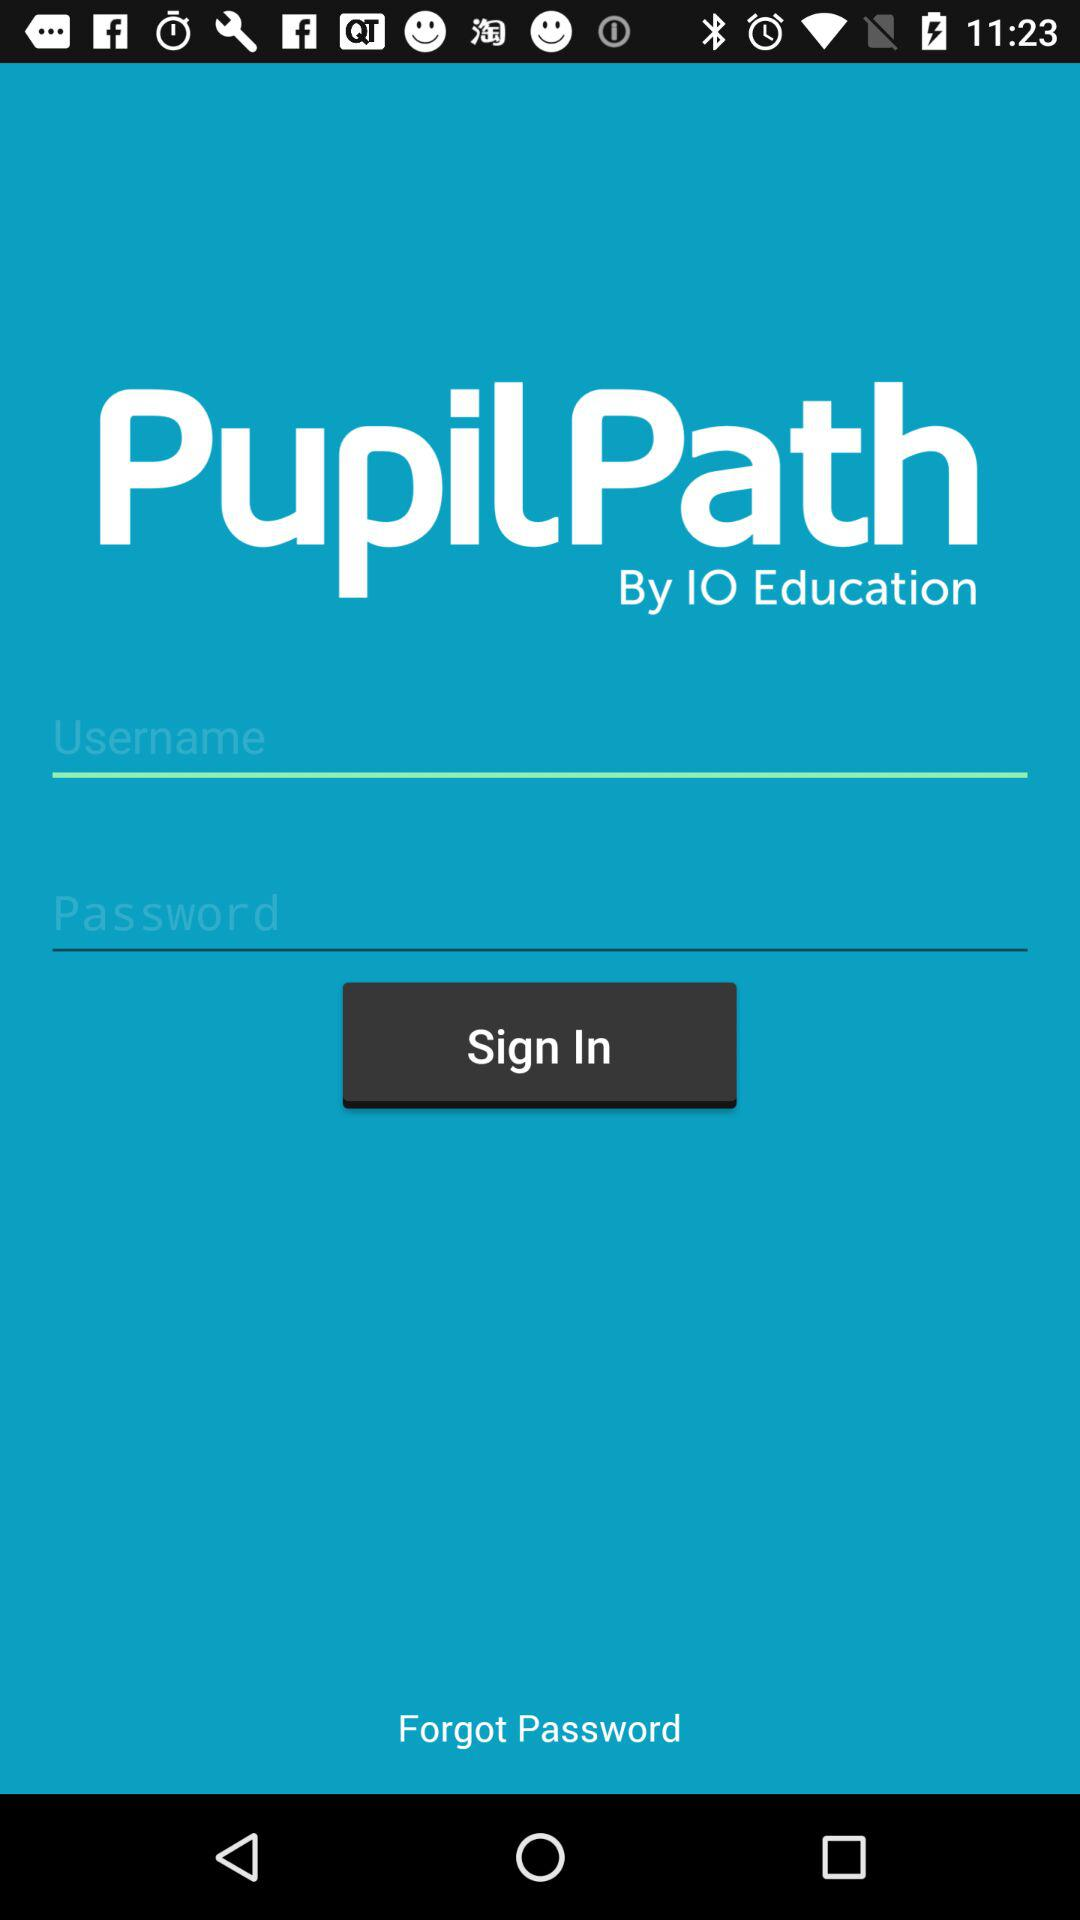By whom does the "PupilPath" application develop? It is developed by IO Education. 